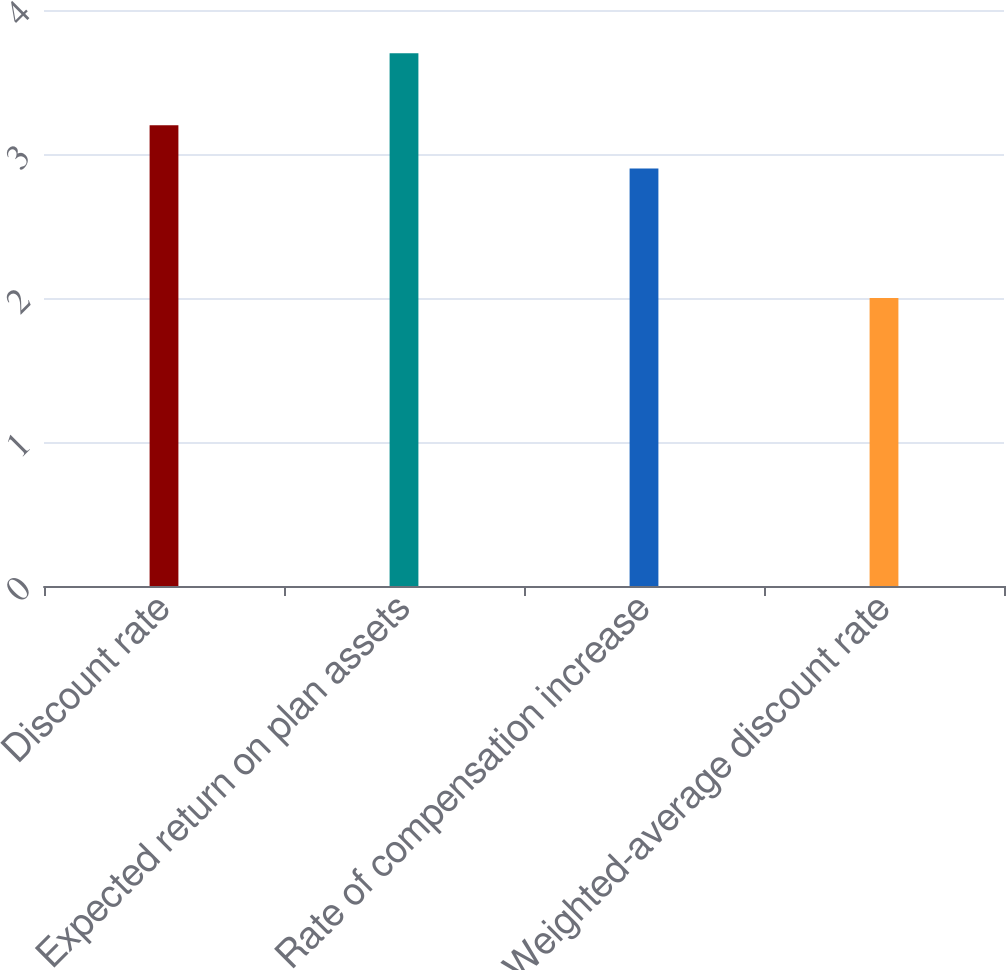Convert chart. <chart><loc_0><loc_0><loc_500><loc_500><bar_chart><fcel>Discount rate<fcel>Expected return on plan assets<fcel>Rate of compensation increase<fcel>Weighted-average discount rate<nl><fcel>3.2<fcel>3.7<fcel>2.9<fcel>2<nl></chart> 